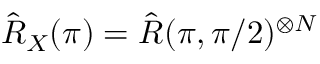<formula> <loc_0><loc_0><loc_500><loc_500>\hat { R } _ { X } ( \pi ) = \hat { R } ( \pi , \pi / 2 ) ^ { \otimes N }</formula> 